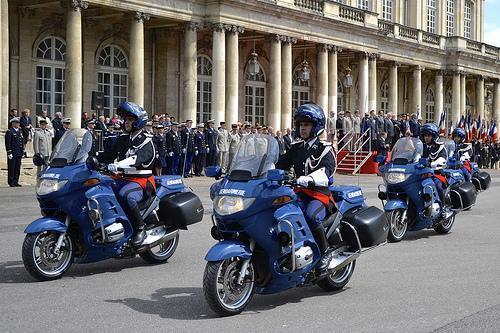How many motorcycles are in the image?
Give a very brief answer. 4. How many wheels does each motorcycle have?
Give a very brief answer. 2. 